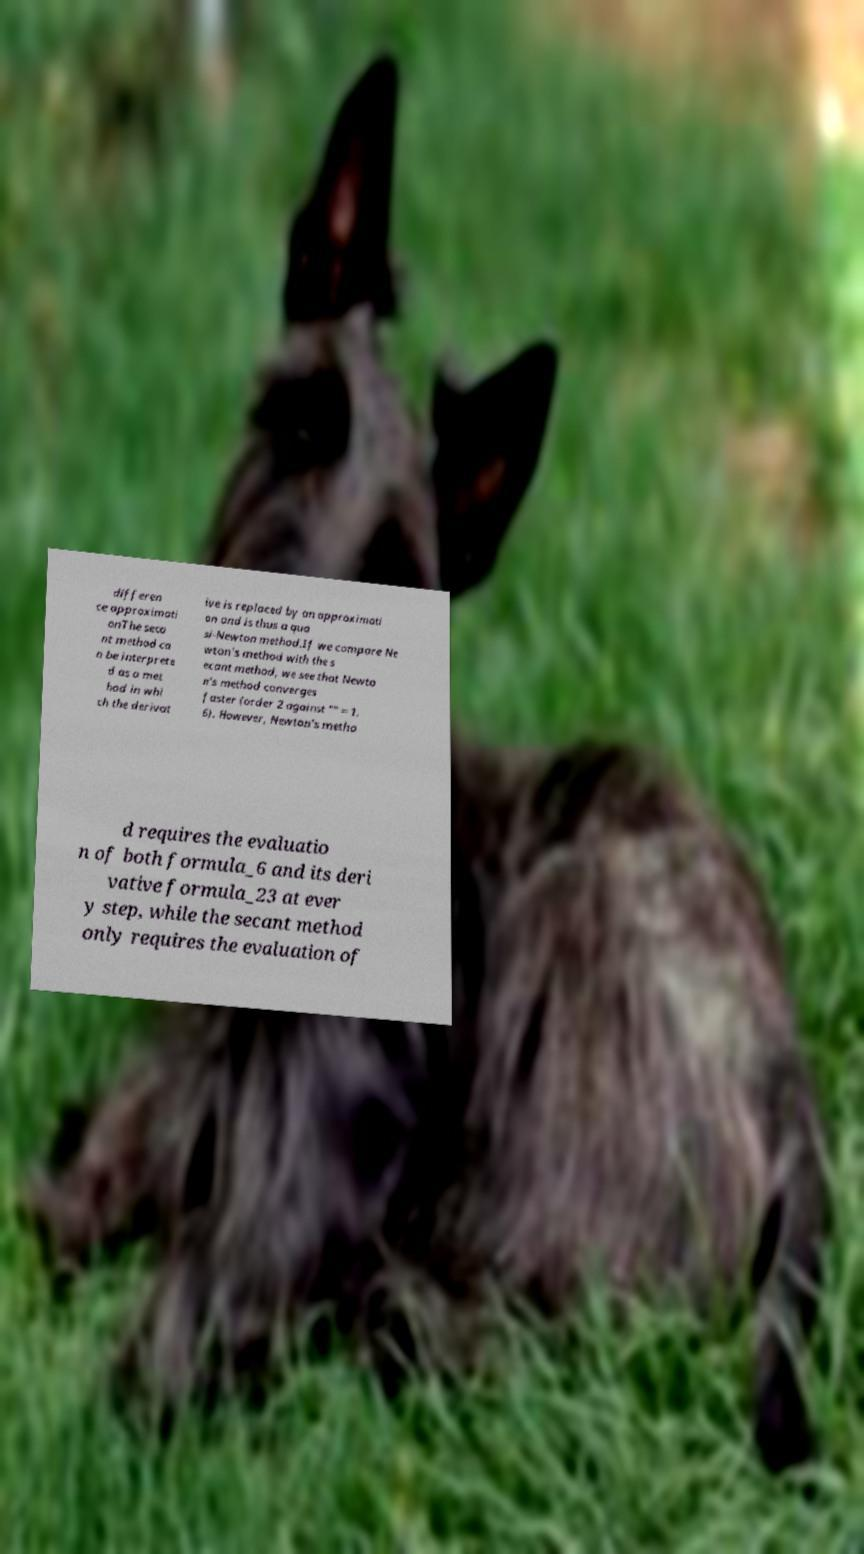Please read and relay the text visible in this image. What does it say? differen ce approximati onThe seca nt method ca n be interprete d as a met hod in whi ch the derivat ive is replaced by an approximati on and is thus a qua si-Newton method.If we compare Ne wton's method with the s ecant method, we see that Newto n's method converges faster (order 2 against "" ≈ 1. 6). However, Newton's metho d requires the evaluatio n of both formula_6 and its deri vative formula_23 at ever y step, while the secant method only requires the evaluation of 